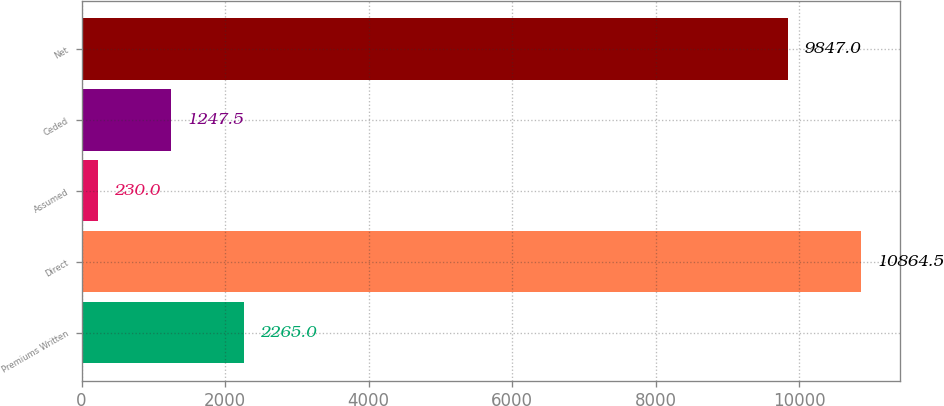<chart> <loc_0><loc_0><loc_500><loc_500><bar_chart><fcel>Premiums Written<fcel>Direct<fcel>Assumed<fcel>Ceded<fcel>Net<nl><fcel>2265<fcel>10864.5<fcel>230<fcel>1247.5<fcel>9847<nl></chart> 